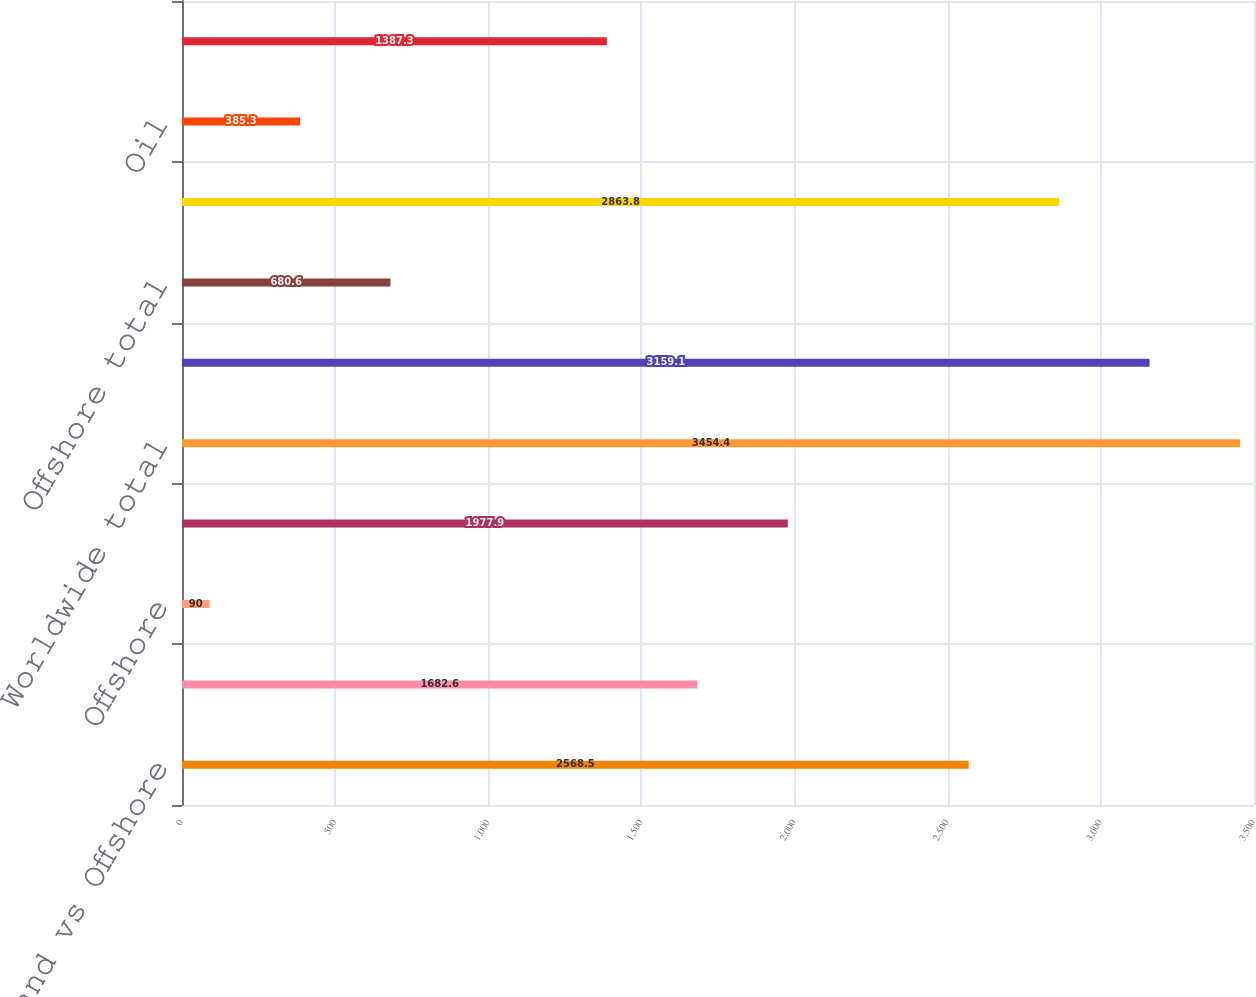<chart> <loc_0><loc_0><loc_500><loc_500><bar_chart><fcel>Land vs Offshore<fcel>Land<fcel>Offshore<fcel>Total<fcel>Worldwide total<fcel>Land total<fcel>Offshore total<fcel>Oil vs Gas<fcel>Oil<fcel>Gas<nl><fcel>2568.5<fcel>1682.6<fcel>90<fcel>1977.9<fcel>3454.4<fcel>3159.1<fcel>680.6<fcel>2863.8<fcel>385.3<fcel>1387.3<nl></chart> 